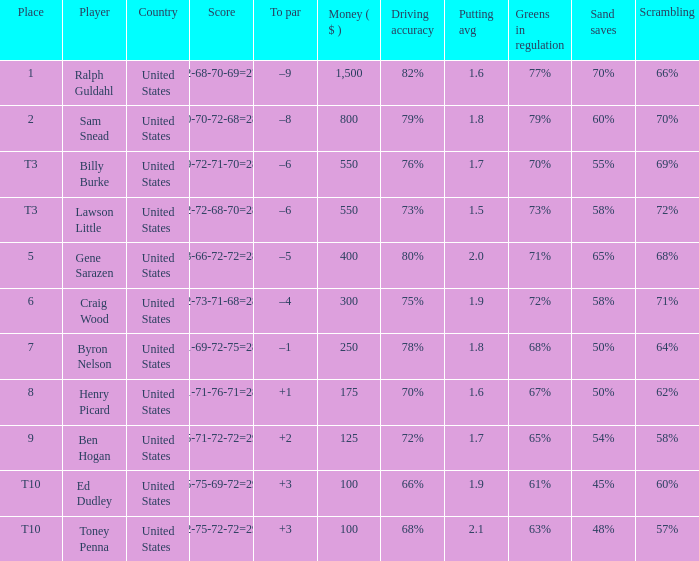Which country has a prize smaller than $250 and the player Henry Picard? United States. 